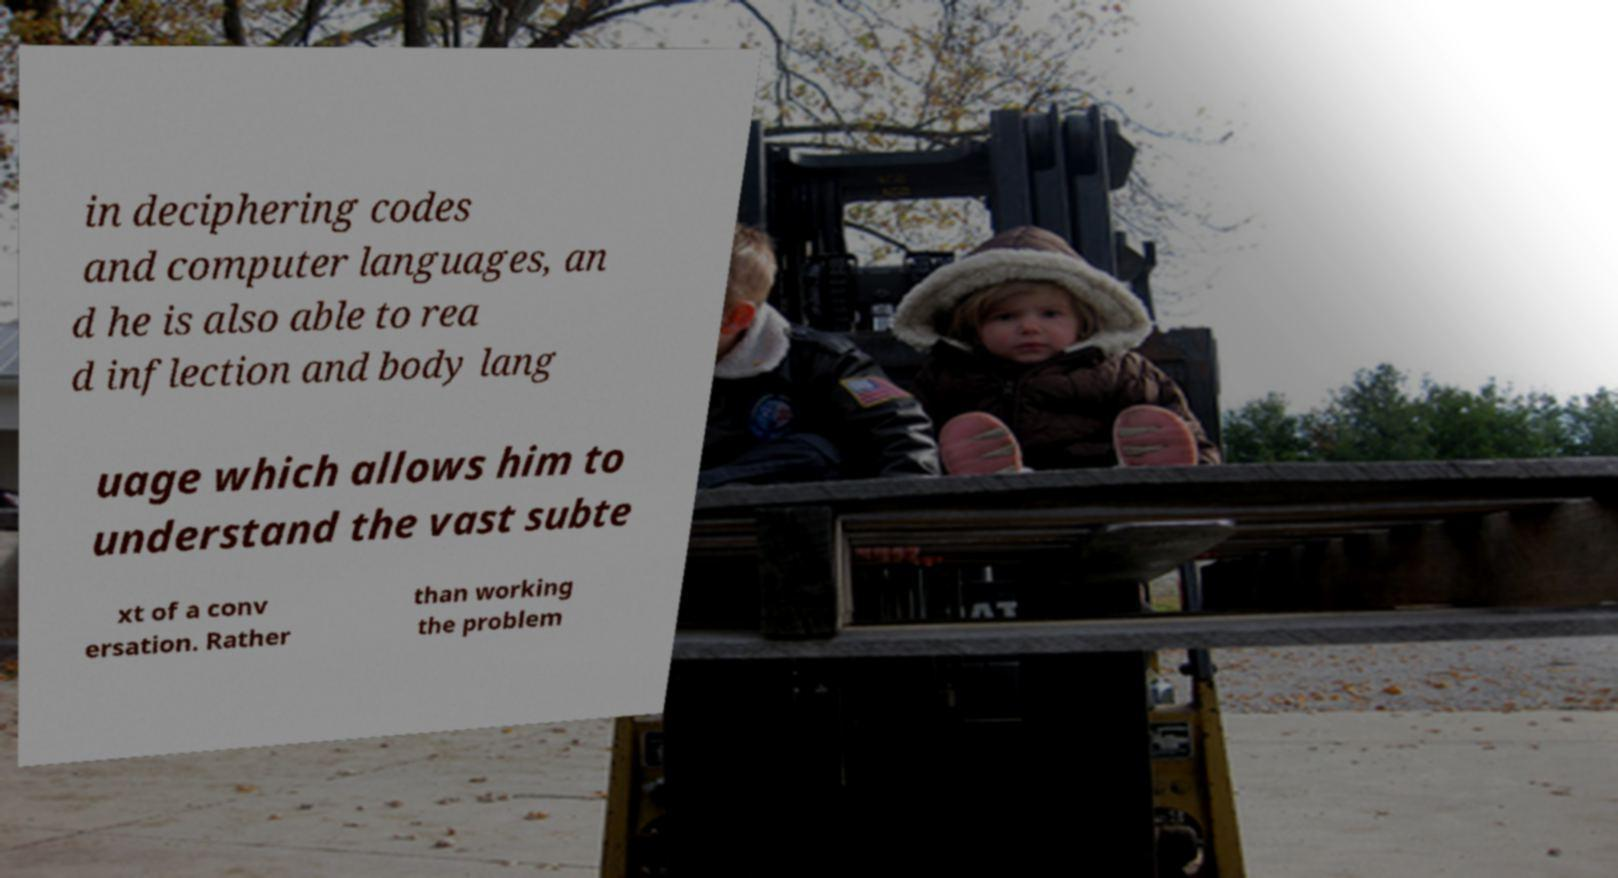There's text embedded in this image that I need extracted. Can you transcribe it verbatim? in deciphering codes and computer languages, an d he is also able to rea d inflection and body lang uage which allows him to understand the vast subte xt of a conv ersation. Rather than working the problem 